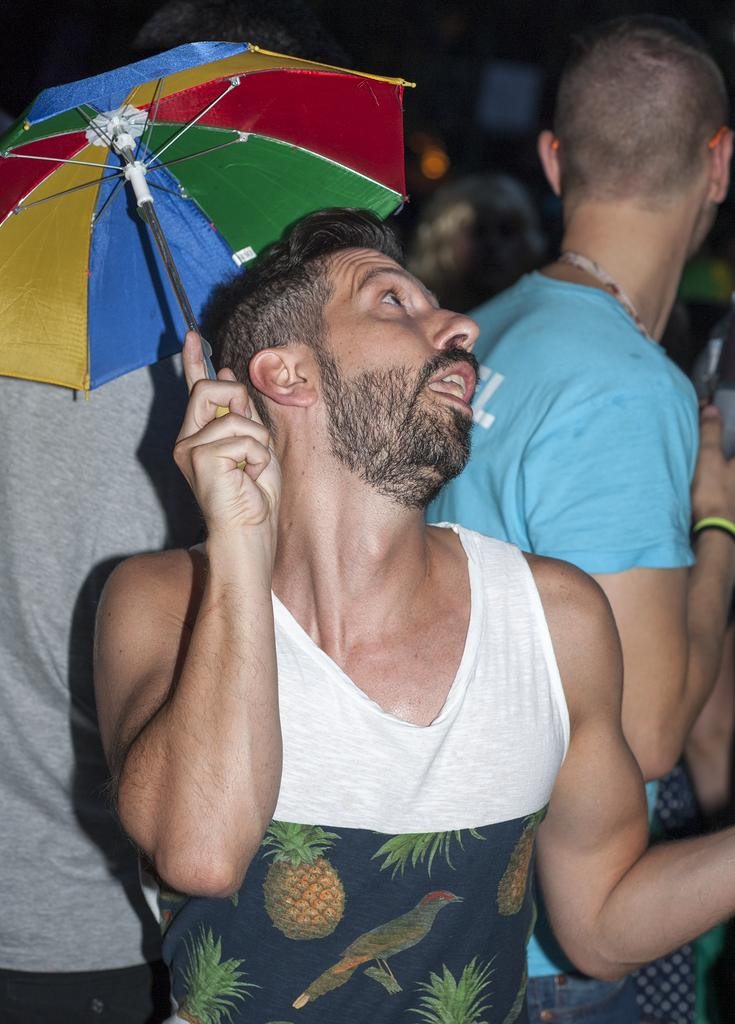What is the main subject in the foreground of the image? There is a man in the foreground of the image. What is the man holding in the image? The man is holding an umbrella. Is the man wearing a crown in the image? There is no mention of a crown in the image, and the man is not depicted as wearing one. What type of medical treatment is the man receiving in the image? There is no indication of any medical treatment being administered in the image. 